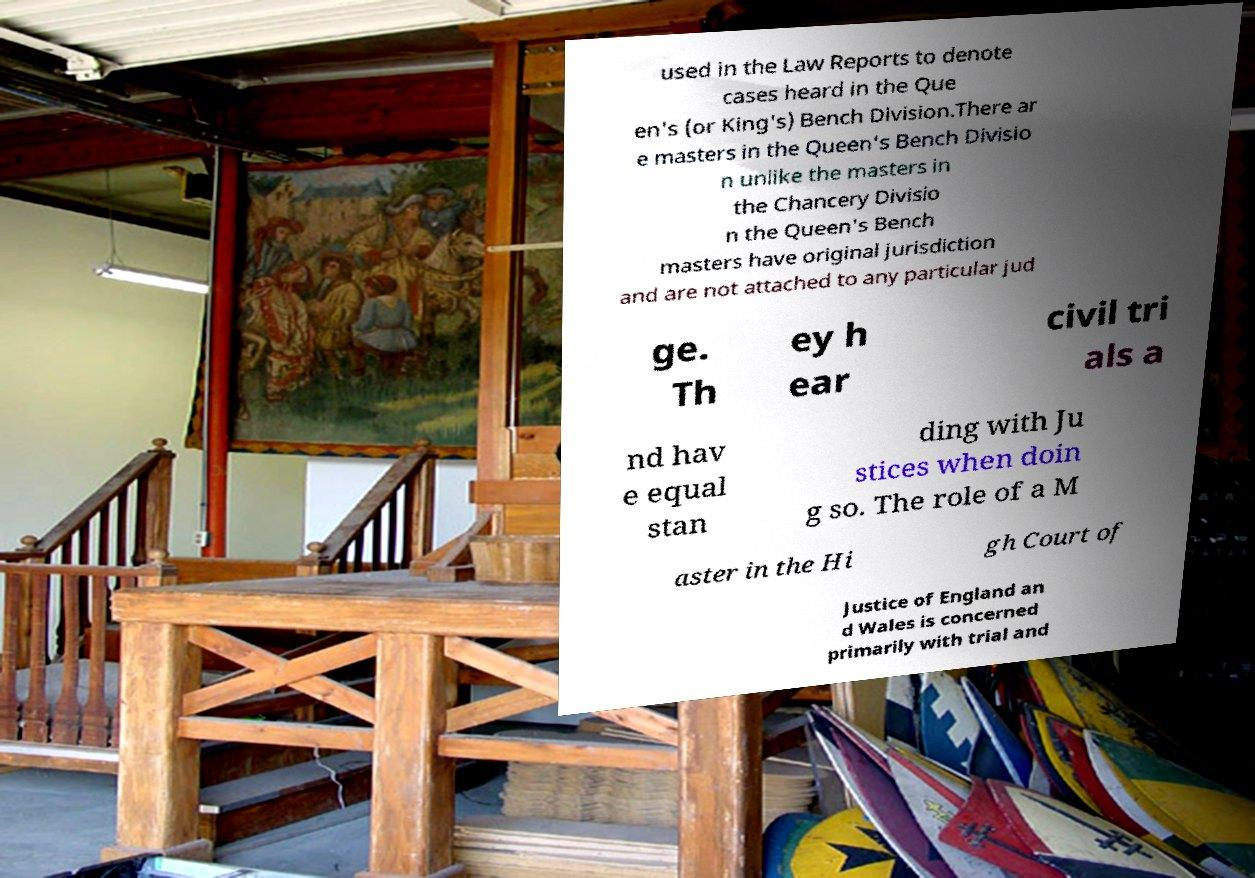For documentation purposes, I need the text within this image transcribed. Could you provide that? used in the Law Reports to denote cases heard in the Que en's (or King's) Bench Division.There ar e masters in the Queen's Bench Divisio n unlike the masters in the Chancery Divisio n the Queen's Bench masters have original jurisdiction and are not attached to any particular jud ge. Th ey h ear civil tri als a nd hav e equal stan ding with Ju stices when doin g so. The role of a M aster in the Hi gh Court of Justice of England an d Wales is concerned primarily with trial and 